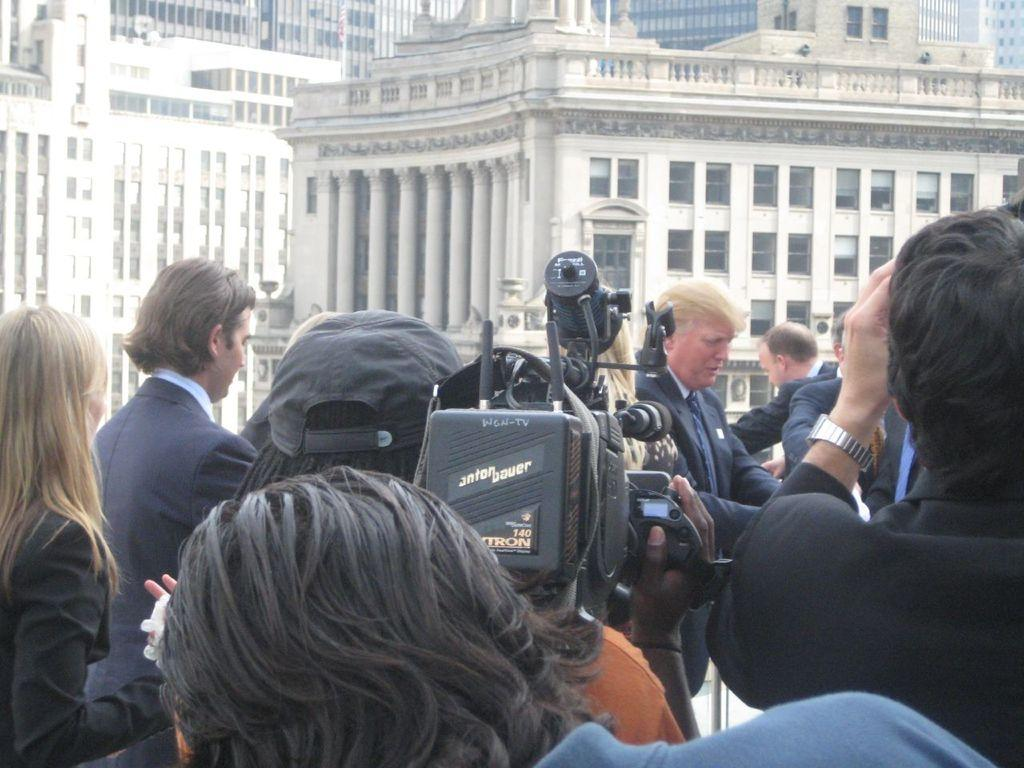How many people are in the image? There is a group of people in the image. What is one person in the group doing? One person in the middle is holding a video camera. What can be seen in the background of the image? There are buildings in the background of the image. What type of gun is being used by the person in the middle of the image? There is no gun present in the image; one person is holding a video camera. What toys can be seen in the hands of the people in the image? There are no toys visible in the image; the people are not holding any toys. 